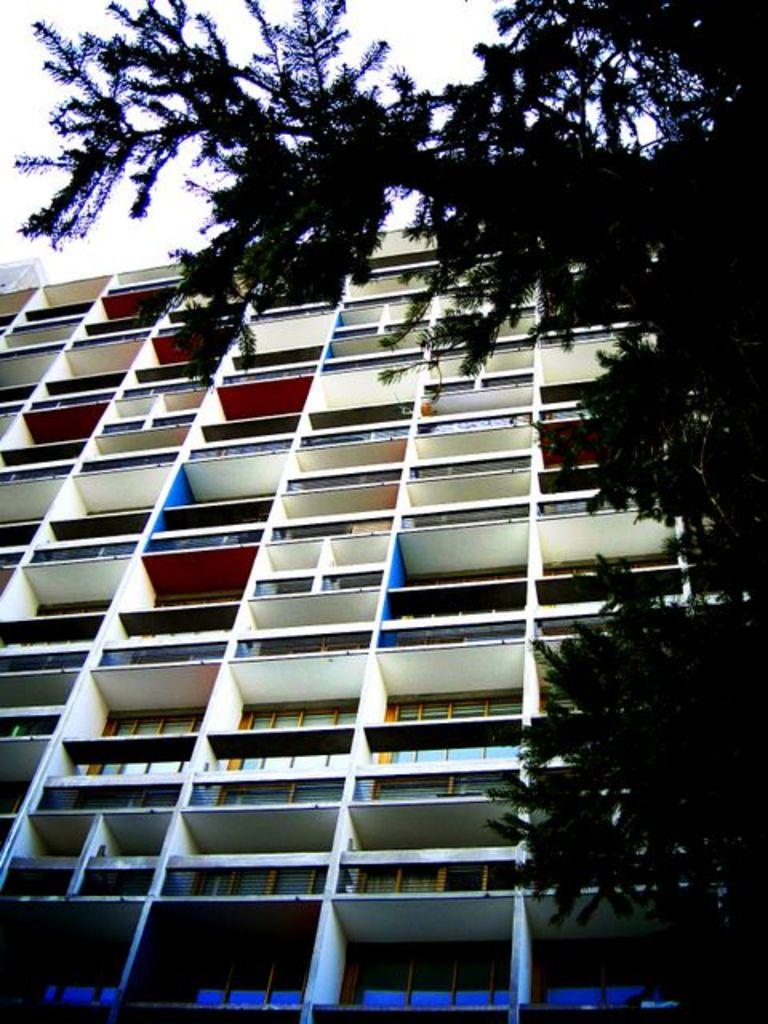What type of building is visible in the image? There is a building with glass windows in the image. What can be seen on the right side of the image? There is a tree on the right side of the image. What is visible at the top of the image? The sky is visible at the top of the image. What type of teaching materials can be seen on the tree in the image? There are no teaching materials or any reference to teaching present in the image. 